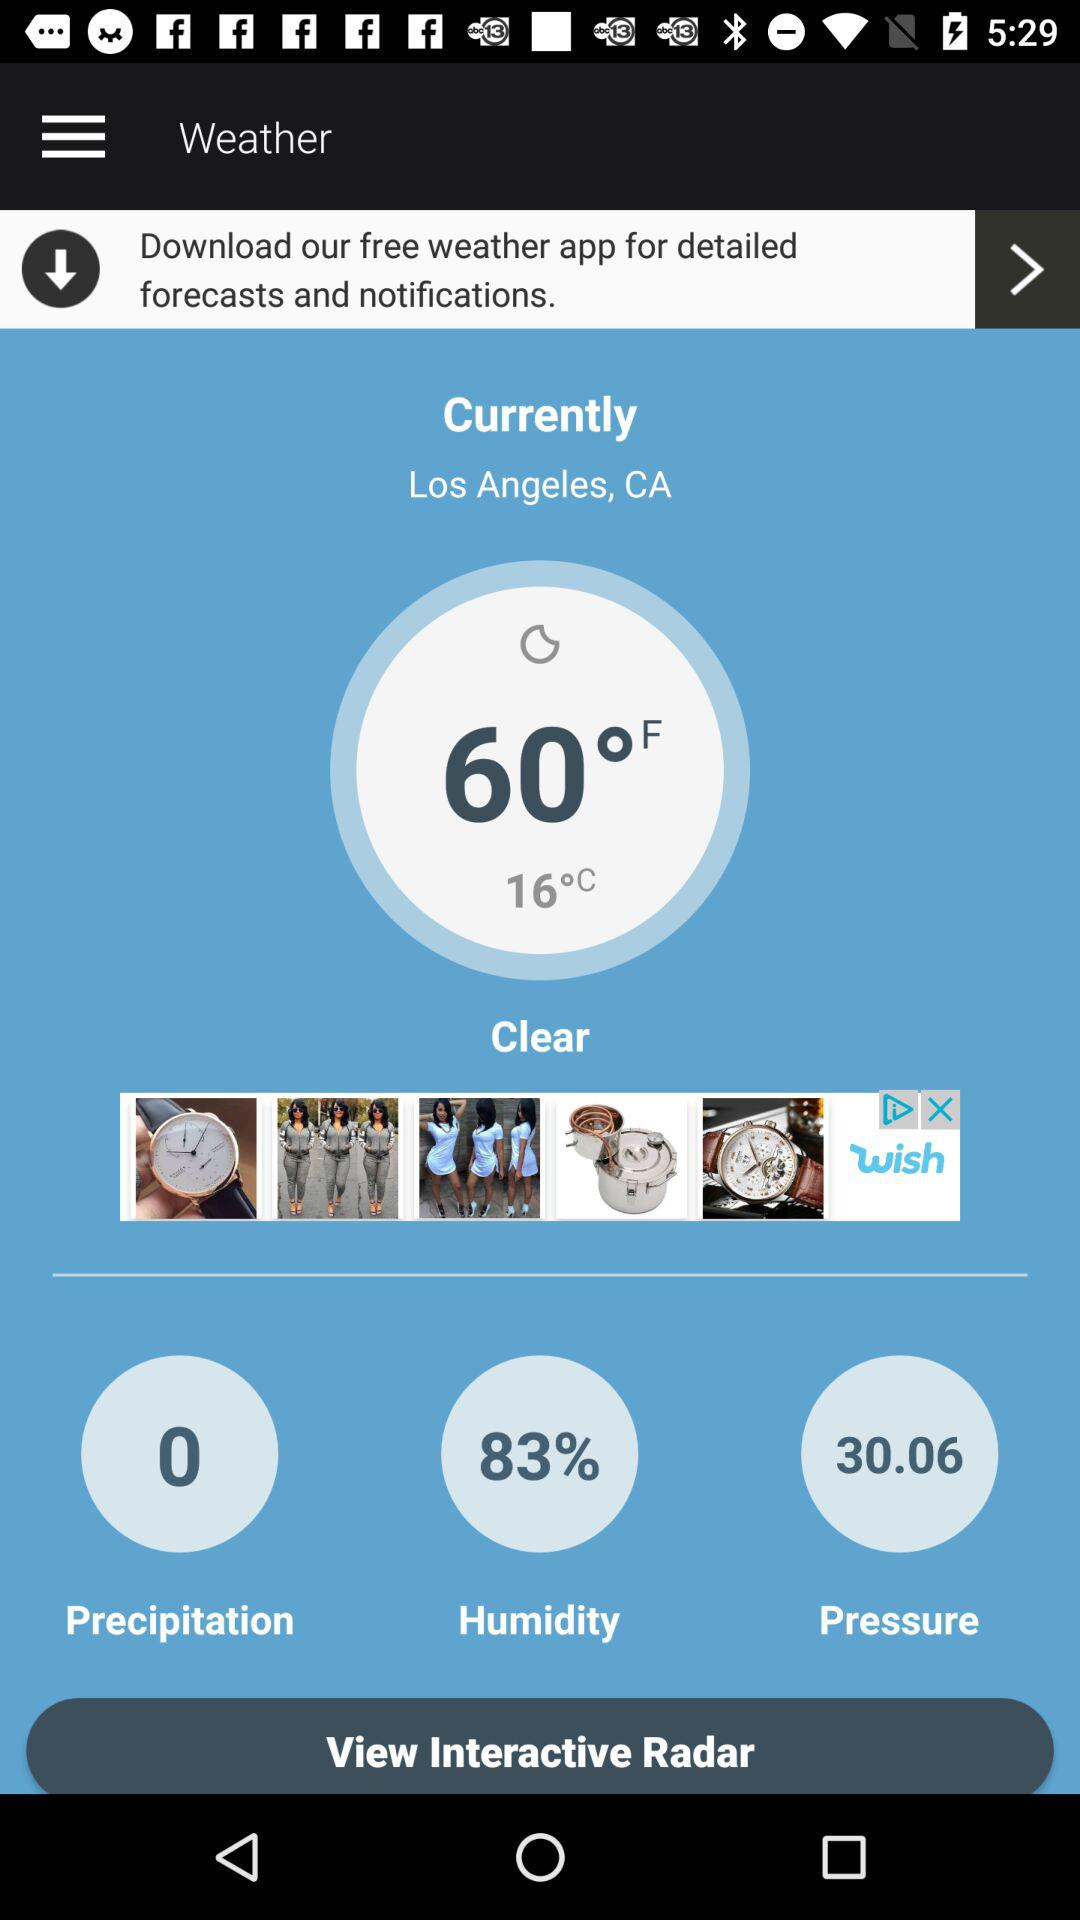What is the relative humidity of the current weather?
Answer the question using a single word or phrase. 83% 